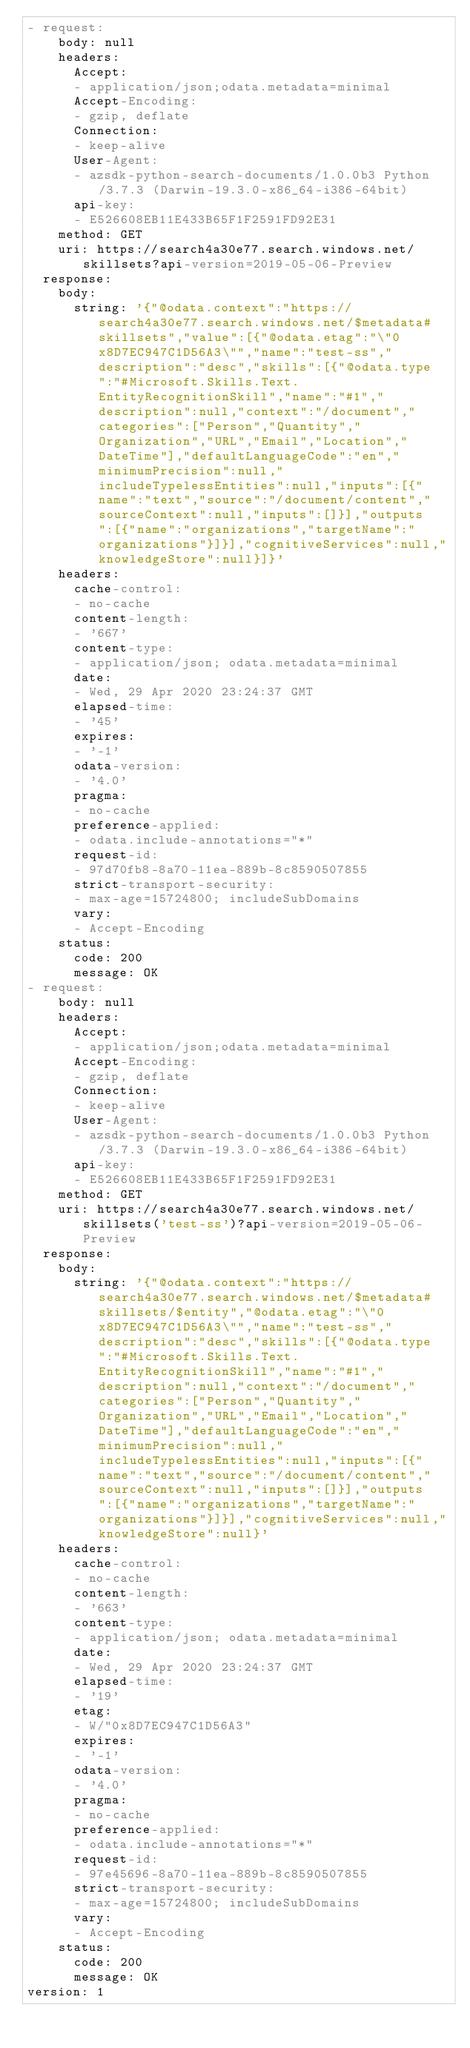<code> <loc_0><loc_0><loc_500><loc_500><_YAML_>- request:
    body: null
    headers:
      Accept:
      - application/json;odata.metadata=minimal
      Accept-Encoding:
      - gzip, deflate
      Connection:
      - keep-alive
      User-Agent:
      - azsdk-python-search-documents/1.0.0b3 Python/3.7.3 (Darwin-19.3.0-x86_64-i386-64bit)
      api-key:
      - E526608EB11E433B65F1F2591FD92E31
    method: GET
    uri: https://search4a30e77.search.windows.net/skillsets?api-version=2019-05-06-Preview
  response:
    body:
      string: '{"@odata.context":"https://search4a30e77.search.windows.net/$metadata#skillsets","value":[{"@odata.etag":"\"0x8D7EC947C1D56A3\"","name":"test-ss","description":"desc","skills":[{"@odata.type":"#Microsoft.Skills.Text.EntityRecognitionSkill","name":"#1","description":null,"context":"/document","categories":["Person","Quantity","Organization","URL","Email","Location","DateTime"],"defaultLanguageCode":"en","minimumPrecision":null,"includeTypelessEntities":null,"inputs":[{"name":"text","source":"/document/content","sourceContext":null,"inputs":[]}],"outputs":[{"name":"organizations","targetName":"organizations"}]}],"cognitiveServices":null,"knowledgeStore":null}]}'
    headers:
      cache-control:
      - no-cache
      content-length:
      - '667'
      content-type:
      - application/json; odata.metadata=minimal
      date:
      - Wed, 29 Apr 2020 23:24:37 GMT
      elapsed-time:
      - '45'
      expires:
      - '-1'
      odata-version:
      - '4.0'
      pragma:
      - no-cache
      preference-applied:
      - odata.include-annotations="*"
      request-id:
      - 97d70fb8-8a70-11ea-889b-8c8590507855
      strict-transport-security:
      - max-age=15724800; includeSubDomains
      vary:
      - Accept-Encoding
    status:
      code: 200
      message: OK
- request:
    body: null
    headers:
      Accept:
      - application/json;odata.metadata=minimal
      Accept-Encoding:
      - gzip, deflate
      Connection:
      - keep-alive
      User-Agent:
      - azsdk-python-search-documents/1.0.0b3 Python/3.7.3 (Darwin-19.3.0-x86_64-i386-64bit)
      api-key:
      - E526608EB11E433B65F1F2591FD92E31
    method: GET
    uri: https://search4a30e77.search.windows.net/skillsets('test-ss')?api-version=2019-05-06-Preview
  response:
    body:
      string: '{"@odata.context":"https://search4a30e77.search.windows.net/$metadata#skillsets/$entity","@odata.etag":"\"0x8D7EC947C1D56A3\"","name":"test-ss","description":"desc","skills":[{"@odata.type":"#Microsoft.Skills.Text.EntityRecognitionSkill","name":"#1","description":null,"context":"/document","categories":["Person","Quantity","Organization","URL","Email","Location","DateTime"],"defaultLanguageCode":"en","minimumPrecision":null,"includeTypelessEntities":null,"inputs":[{"name":"text","source":"/document/content","sourceContext":null,"inputs":[]}],"outputs":[{"name":"organizations","targetName":"organizations"}]}],"cognitiveServices":null,"knowledgeStore":null}'
    headers:
      cache-control:
      - no-cache
      content-length:
      - '663'
      content-type:
      - application/json; odata.metadata=minimal
      date:
      - Wed, 29 Apr 2020 23:24:37 GMT
      elapsed-time:
      - '19'
      etag:
      - W/"0x8D7EC947C1D56A3"
      expires:
      - '-1'
      odata-version:
      - '4.0'
      pragma:
      - no-cache
      preference-applied:
      - odata.include-annotations="*"
      request-id:
      - 97e45696-8a70-11ea-889b-8c8590507855
      strict-transport-security:
      - max-age=15724800; includeSubDomains
      vary:
      - Accept-Encoding
    status:
      code: 200
      message: OK
version: 1
</code> 